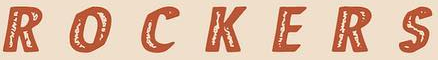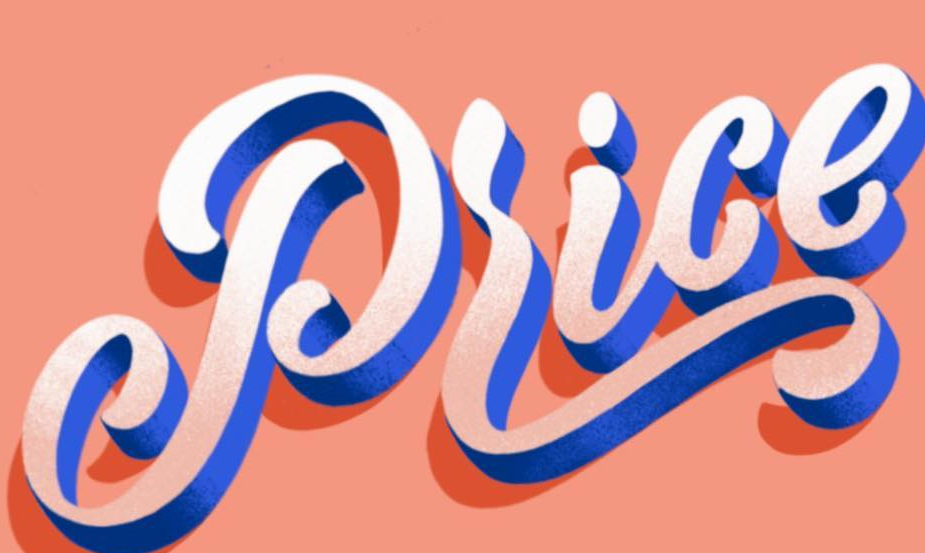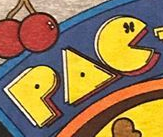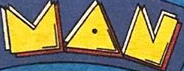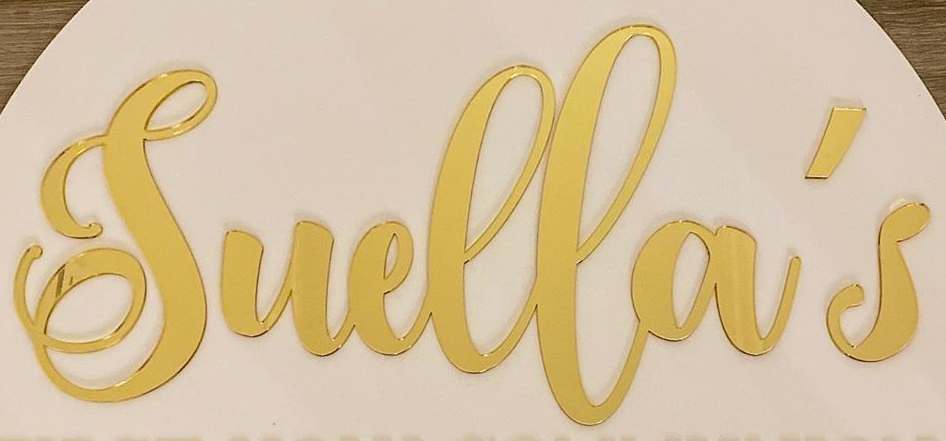Read the text content from these images in order, separated by a semicolon. ROCKERS; Price; PAC; MAN; Suella's 